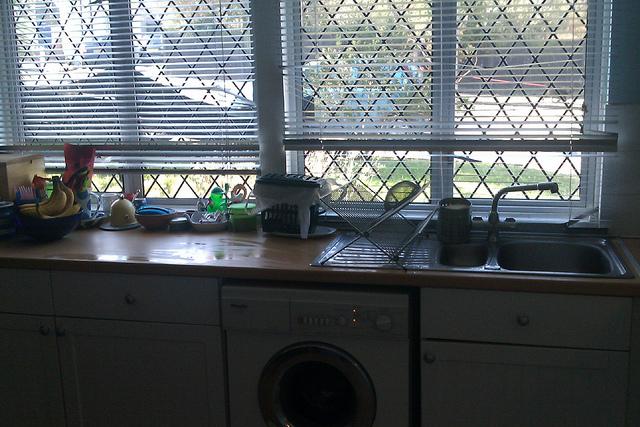Are there iron bars on the windows?
Quick response, please. Yes. Where is the washer?
Answer briefly. Kitchen. Are the two sides of the sink divided equally?
Write a very short answer. No. 